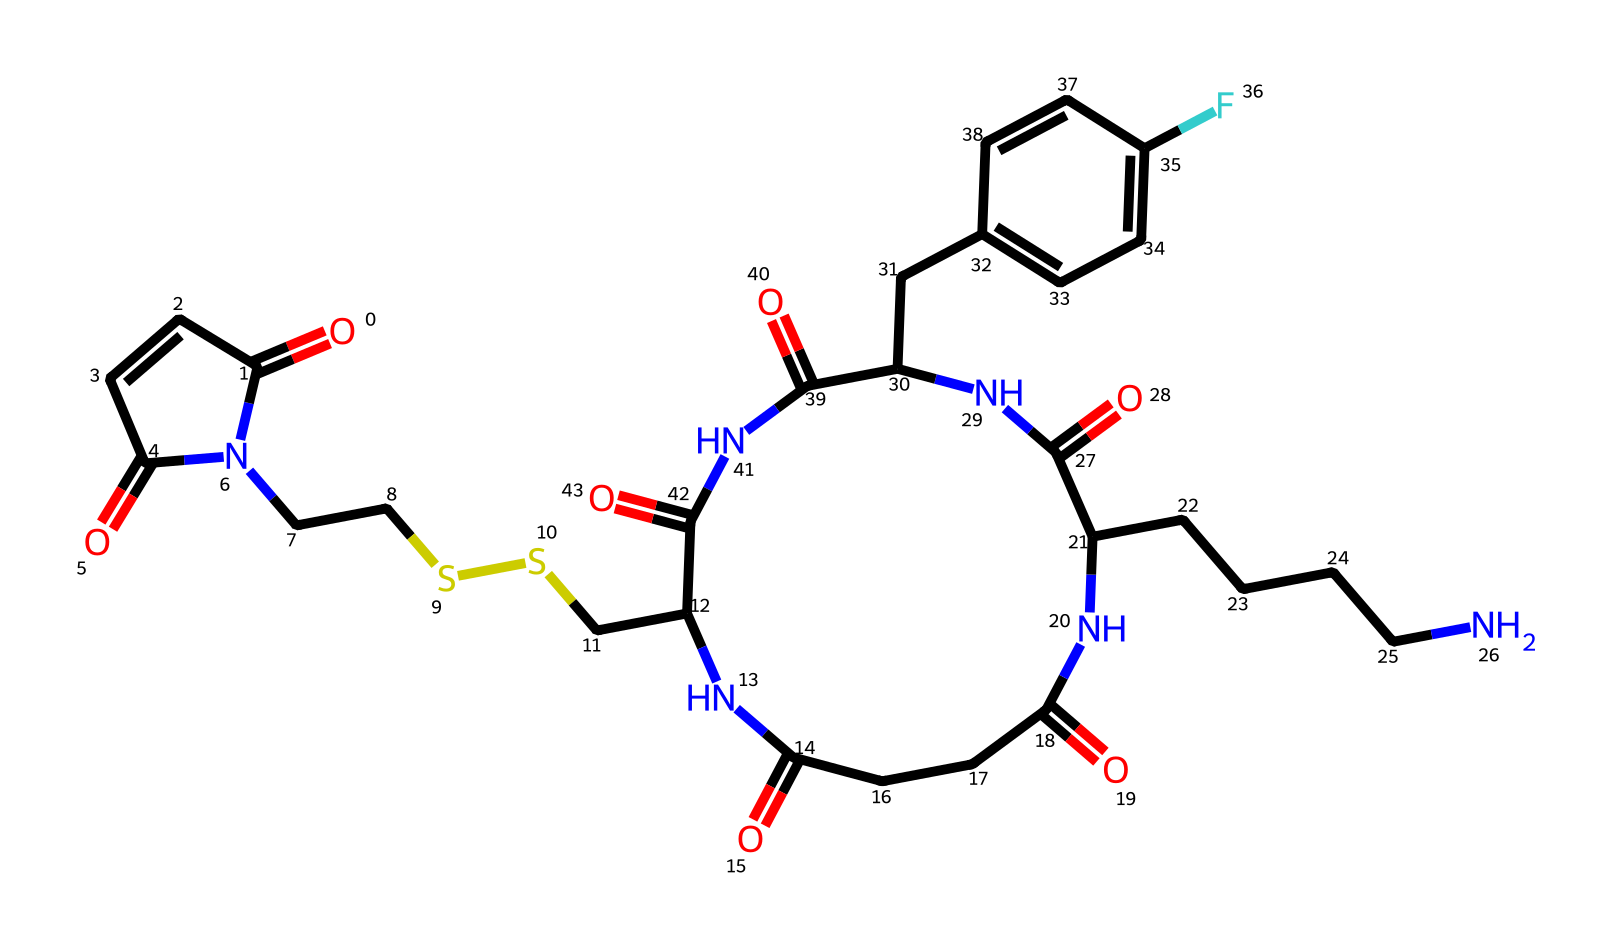What is the total number of nitrogen atoms in the structure? By carefully analyzing the provided SMILES representation, we can count the occurrences of nitrogen (N) in the structure. There are 4 instances of nitrogen in the chemical.
Answer: 4 How many carbon atoms are in this chemical? To determine the number of carbon (C) atoms, we check the SMILES representation for all the carbon symbols. After counting every carbon symbol present, we find there are 19 carbon atoms in total.
Answer: 19 What characterizes this compound as an imide? Imides are characterized by having a -C(=O)N(C)- structure, which is consistently present in the chemical structure; this means that it has both a carbonyl and a nitrogen atom connected in a cyclic or acyclic manner.
Answer: it contains carbonyl and nitrogen How many carbonyl groups are present in the structure? A carbonyl group (C=O) can be identified by looking for the C=O bonds in the SMILES notation. After identifying these, we see there are 5 carbonyl (C=O) groups in the compound.
Answer: 5 What functional group is suggested by the presence of multiple -C(=O)N- units? The presence of multiple -C(=O)N- units indicates that this compound has imide functional groups, which are derived from the reaction of an anhydride with an amine.
Answer: imide groups Which section of the SMILES indicates a potential reaction site for protein labeling? The presence of the maleimide structure -C(=O)N- indicating the reactive part of the compound is likely to participate in nucleophilic addition reactions with thiols from proteins, making it particularly suitable for protein labeling.
Answer: maleimide structure 